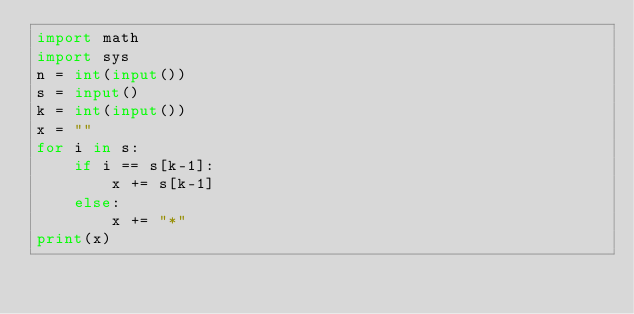<code> <loc_0><loc_0><loc_500><loc_500><_Python_>import math
import sys
n = int(input())
s = input()
k = int(input())
x = ""
for i in s:
    if i == s[k-1]:
        x += s[k-1]
    else:
        x += "*"
print(x)
</code> 